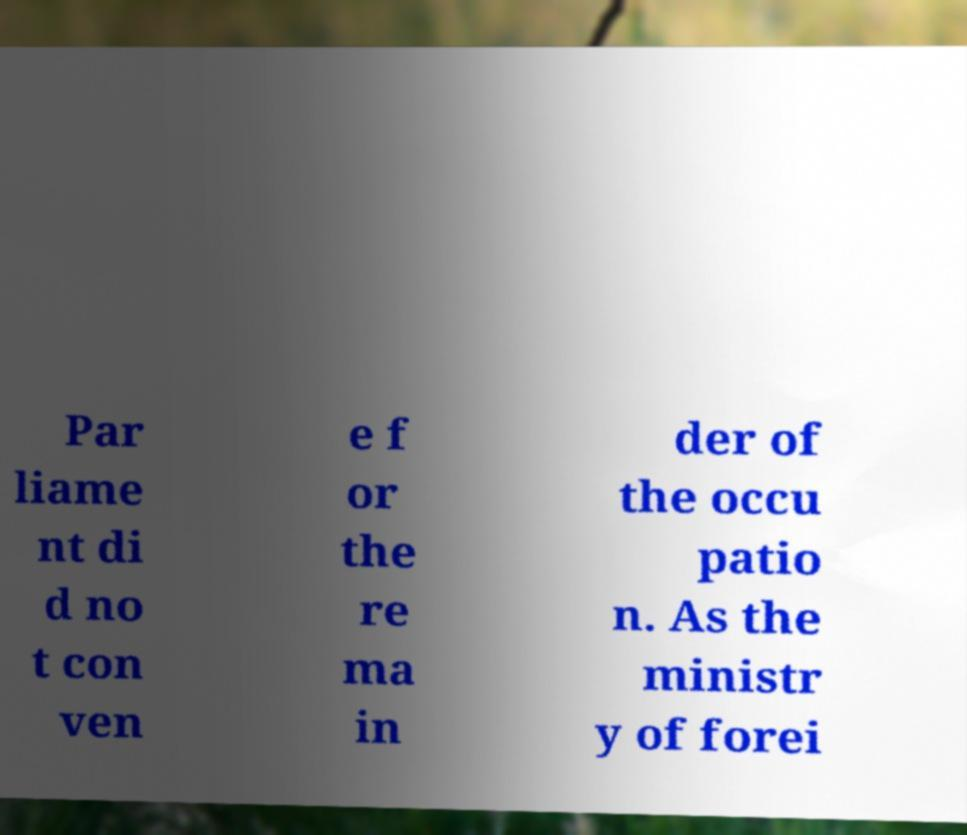What messages or text are displayed in this image? I need them in a readable, typed format. Par liame nt di d no t con ven e f or the re ma in der of the occu patio n. As the ministr y of forei 